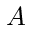Convert formula to latex. <formula><loc_0><loc_0><loc_500><loc_500>A</formula> 